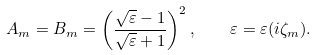<formula> <loc_0><loc_0><loc_500><loc_500>A _ { m } = B _ { m } = \left ( \frac { \sqrt { \varepsilon } - 1 } { \sqrt { \varepsilon } + 1 } \right ) ^ { 2 } , \quad \varepsilon = \varepsilon ( i \zeta _ { m } ) .</formula> 